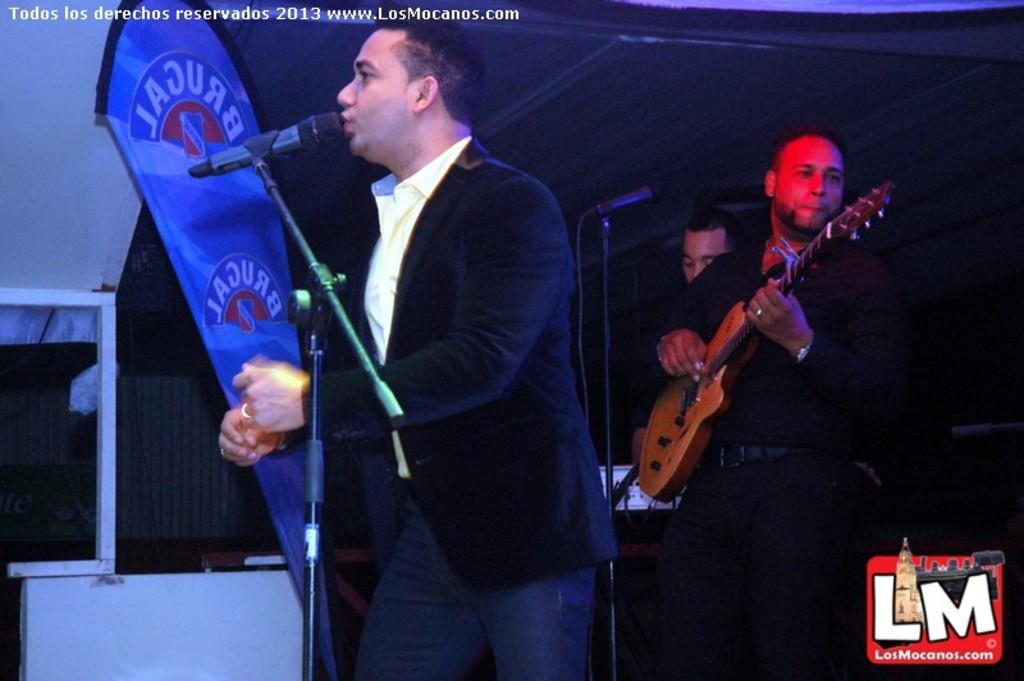What is the main activity being performed by the person in the image? There is a person playing a guitar in the image. Can you describe the other person in the image? There is another person speaking on a microphone in the image. What type of structure can be seen in the background? There is a shed in the image. What other type of structure is visible in the image? There is a building in the image. What type of sock is the mother wearing in the image? There is no mention of a mother or a sock in the image; it features a person playing a guitar and another person speaking on a microphone, along with a shed and a building in the background. 